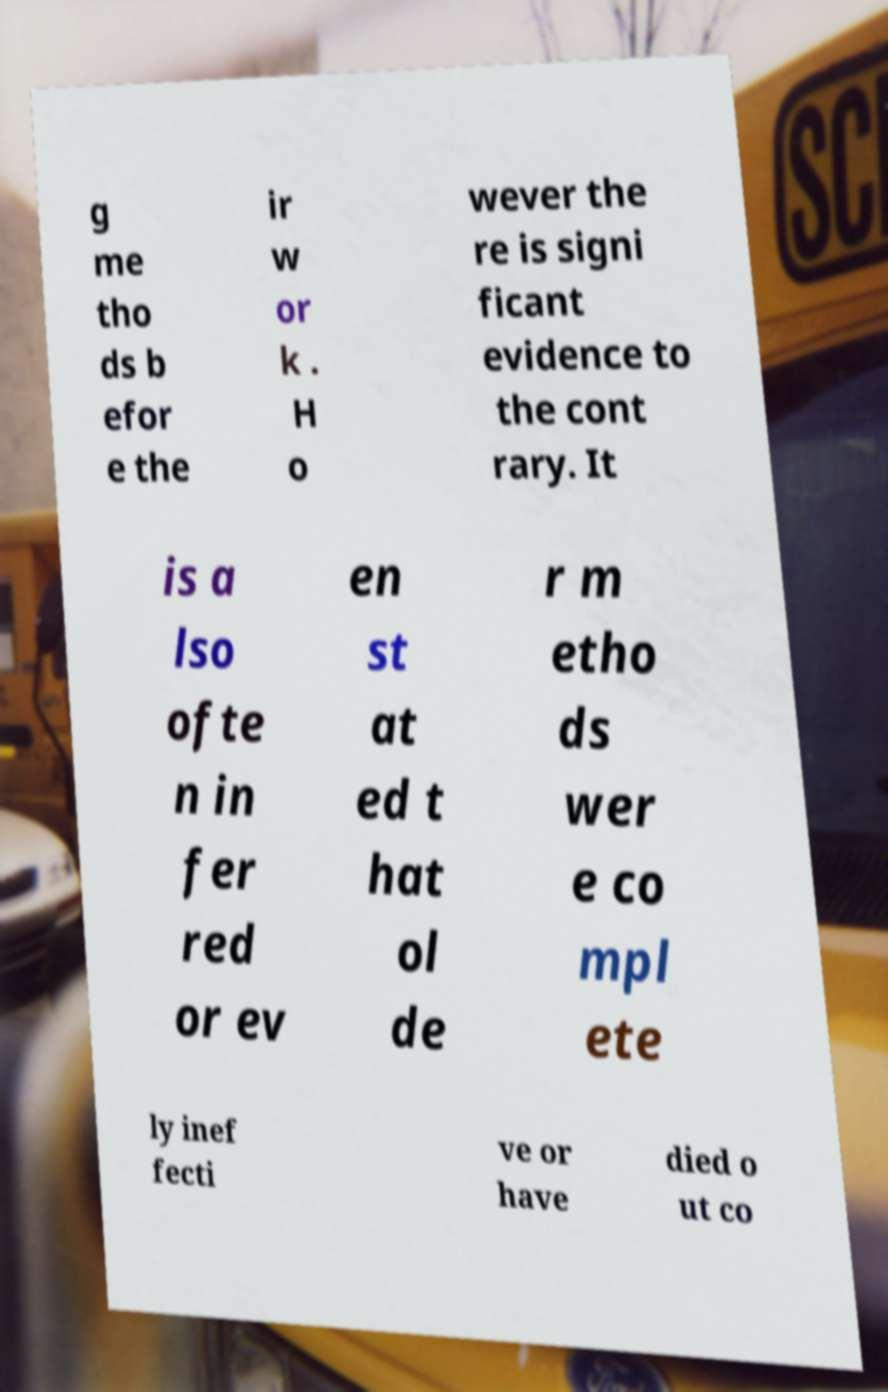There's text embedded in this image that I need extracted. Can you transcribe it verbatim? g me tho ds b efor e the ir w or k . H o wever the re is signi ficant evidence to the cont rary. It is a lso ofte n in fer red or ev en st at ed t hat ol de r m etho ds wer e co mpl ete ly inef fecti ve or have died o ut co 